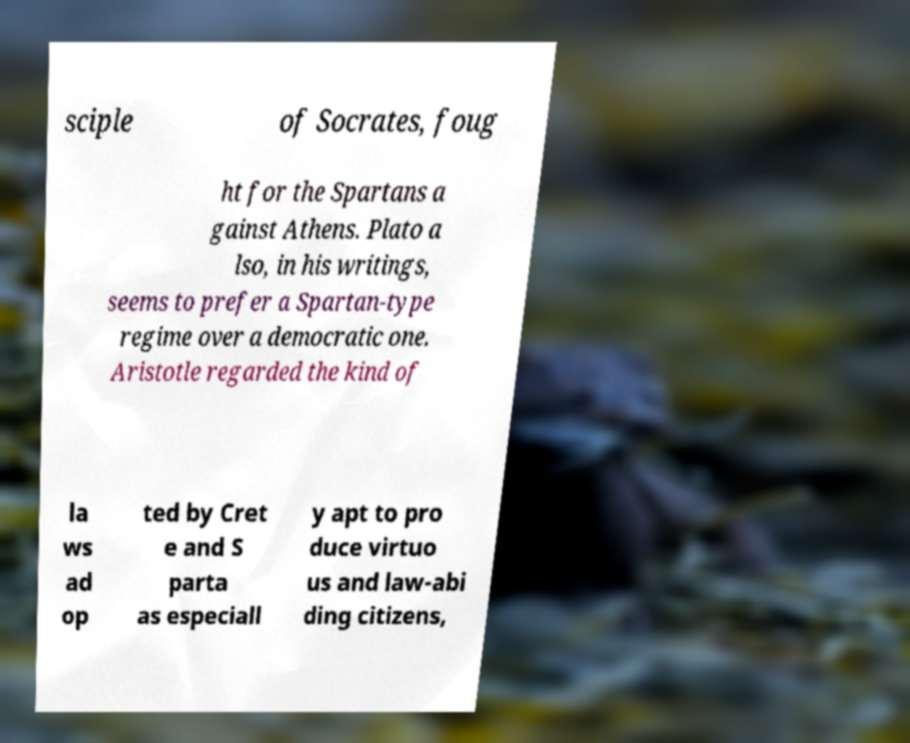Could you assist in decoding the text presented in this image and type it out clearly? sciple of Socrates, foug ht for the Spartans a gainst Athens. Plato a lso, in his writings, seems to prefer a Spartan-type regime over a democratic one. Aristotle regarded the kind of la ws ad op ted by Cret e and S parta as especiall y apt to pro duce virtuo us and law-abi ding citizens, 